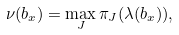<formula> <loc_0><loc_0><loc_500><loc_500>\nu ( b _ { x } ) = \max _ { J } \pi _ { J } ( \lambda ( b _ { x } ) ) ,</formula> 